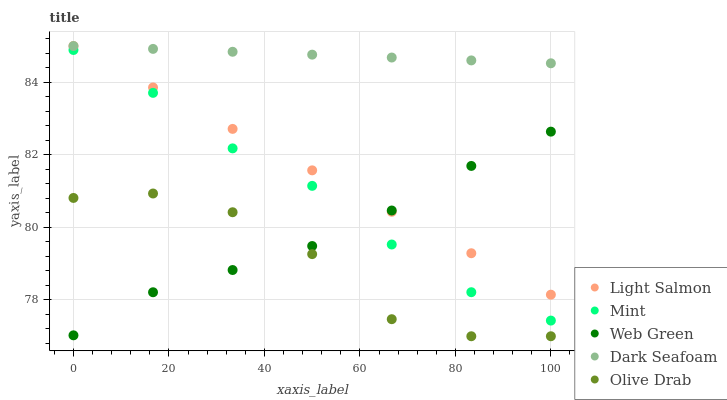Does Olive Drab have the minimum area under the curve?
Answer yes or no. Yes. Does Dark Seafoam have the maximum area under the curve?
Answer yes or no. Yes. Does Light Salmon have the minimum area under the curve?
Answer yes or no. No. Does Light Salmon have the maximum area under the curve?
Answer yes or no. No. Is Dark Seafoam the smoothest?
Answer yes or no. Yes. Is Olive Drab the roughest?
Answer yes or no. Yes. Is Light Salmon the smoothest?
Answer yes or no. No. Is Light Salmon the roughest?
Answer yes or no. No. Does Olive Drab have the lowest value?
Answer yes or no. Yes. Does Light Salmon have the lowest value?
Answer yes or no. No. Does Dark Seafoam have the highest value?
Answer yes or no. Yes. Does Mint have the highest value?
Answer yes or no. No. Is Mint less than Light Salmon?
Answer yes or no. Yes. Is Dark Seafoam greater than Web Green?
Answer yes or no. Yes. Does Dark Seafoam intersect Light Salmon?
Answer yes or no. Yes. Is Dark Seafoam less than Light Salmon?
Answer yes or no. No. Is Dark Seafoam greater than Light Salmon?
Answer yes or no. No. Does Mint intersect Light Salmon?
Answer yes or no. No. 